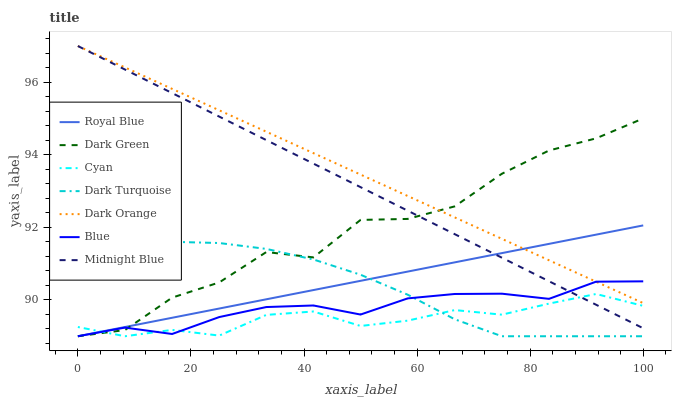Does Cyan have the minimum area under the curve?
Answer yes or no. Yes. Does Dark Orange have the maximum area under the curve?
Answer yes or no. Yes. Does Midnight Blue have the minimum area under the curve?
Answer yes or no. No. Does Midnight Blue have the maximum area under the curve?
Answer yes or no. No. Is Midnight Blue the smoothest?
Answer yes or no. Yes. Is Dark Green the roughest?
Answer yes or no. Yes. Is Dark Orange the smoothest?
Answer yes or no. No. Is Dark Orange the roughest?
Answer yes or no. No. Does Blue have the lowest value?
Answer yes or no. Yes. Does Midnight Blue have the lowest value?
Answer yes or no. No. Does Midnight Blue have the highest value?
Answer yes or no. Yes. Does Dark Turquoise have the highest value?
Answer yes or no. No. Is Cyan less than Dark Orange?
Answer yes or no. Yes. Is Midnight Blue greater than Dark Turquoise?
Answer yes or no. Yes. Does Cyan intersect Royal Blue?
Answer yes or no. Yes. Is Cyan less than Royal Blue?
Answer yes or no. No. Is Cyan greater than Royal Blue?
Answer yes or no. No. Does Cyan intersect Dark Orange?
Answer yes or no. No. 